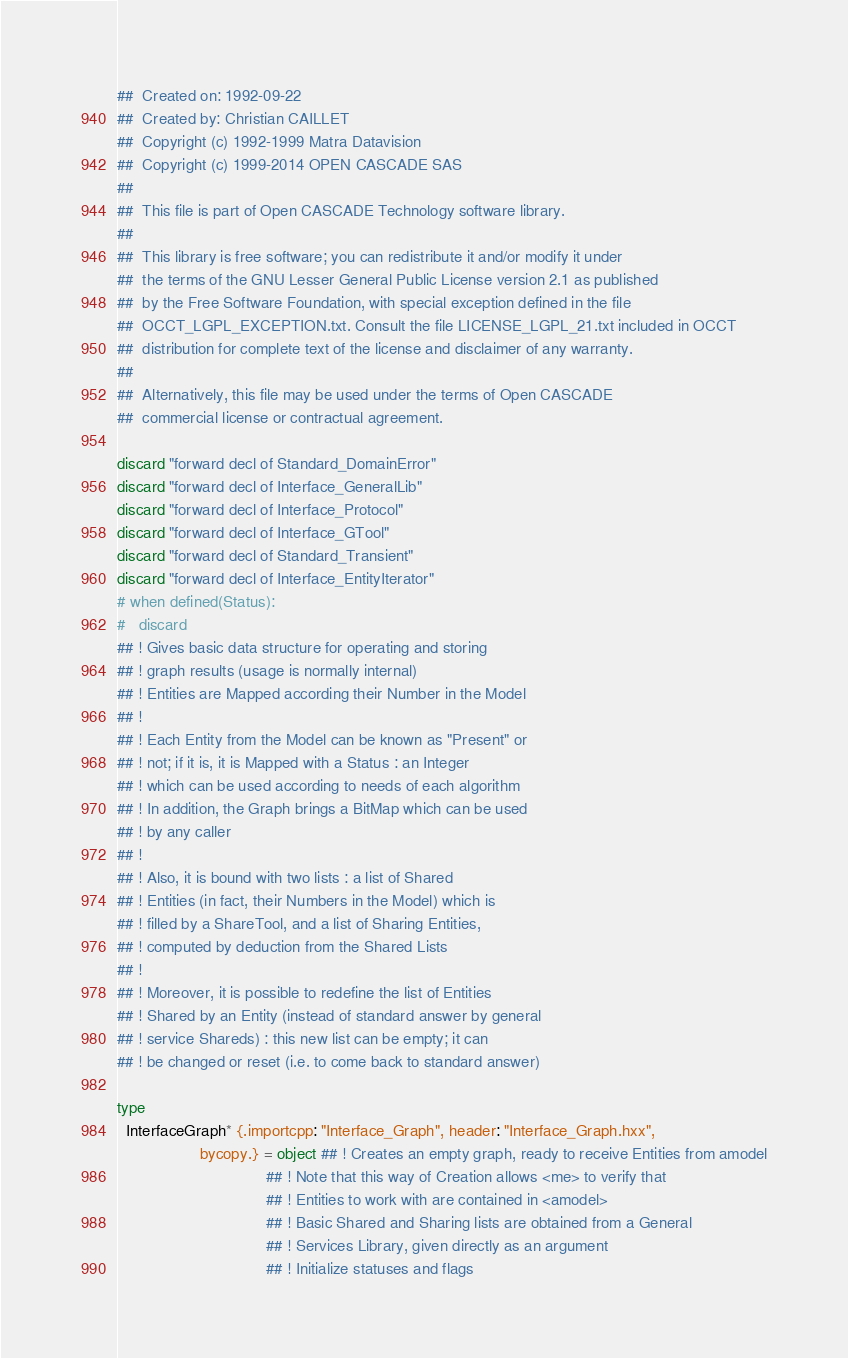Convert code to text. <code><loc_0><loc_0><loc_500><loc_500><_Nim_>##  Created on: 1992-09-22
##  Created by: Christian CAILLET
##  Copyright (c) 1992-1999 Matra Datavision
##  Copyright (c) 1999-2014 OPEN CASCADE SAS
##
##  This file is part of Open CASCADE Technology software library.
##
##  This library is free software; you can redistribute it and/or modify it under
##  the terms of the GNU Lesser General Public License version 2.1 as published
##  by the Free Software Foundation, with special exception defined in the file
##  OCCT_LGPL_EXCEPTION.txt. Consult the file LICENSE_LGPL_21.txt included in OCCT
##  distribution for complete text of the license and disclaimer of any warranty.
##
##  Alternatively, this file may be used under the terms of Open CASCADE
##  commercial license or contractual agreement.

discard "forward decl of Standard_DomainError"
discard "forward decl of Interface_GeneralLib"
discard "forward decl of Interface_Protocol"
discard "forward decl of Interface_GTool"
discard "forward decl of Standard_Transient"
discard "forward decl of Interface_EntityIterator"
# when defined(Status):
#   discard
## ! Gives basic data structure for operating and storing
## ! graph results (usage is normally internal)
## ! Entities are Mapped according their Number in the Model
## !
## ! Each Entity from the Model can be known as "Present" or
## ! not; if it is, it is Mapped with a Status : an Integer
## ! which can be used according to needs of each algorithm
## ! In addition, the Graph brings a BitMap which can be used
## ! by any caller
## !
## ! Also, it is bound with two lists : a list of Shared
## ! Entities (in fact, their Numbers in the Model) which is
## ! filled by a ShareTool, and a list of Sharing Entities,
## ! computed by deduction from the Shared Lists
## !
## ! Moreover, it is possible to redefine the list of Entities
## ! Shared by an Entity (instead of standard answer by general
## ! service Shareds) : this new list can be empty; it can
## ! be changed or reset (i.e. to come back to standard answer)

type
  InterfaceGraph* {.importcpp: "Interface_Graph", header: "Interface_Graph.hxx",
                   bycopy.} = object ## ! Creates an empty graph, ready to receive Entities from amodel
                                  ## ! Note that this way of Creation allows <me> to verify that
                                  ## ! Entities to work with are contained in <amodel>
                                  ## ! Basic Shared and Sharing lists are obtained from a General
                                  ## ! Services Library, given directly as an argument
                                  ## ! Initialize statuses and flags</code> 